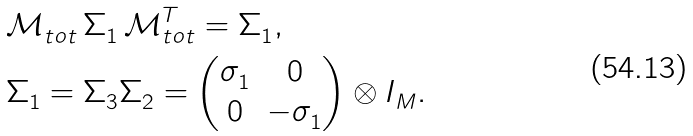Convert formula to latex. <formula><loc_0><loc_0><loc_500><loc_500>& \mathcal { M } ^ { \ } _ { t o t } \, \Sigma ^ { \ } _ { 1 } \, \mathcal { M } ^ { T } _ { t o t } = \Sigma ^ { \ } _ { 1 } , \\ & \Sigma ^ { \ } _ { 1 } = \Sigma ^ { \ } _ { 3 } \Sigma ^ { \ } _ { 2 } = \begin{pmatrix} \sigma ^ { \ } _ { 1 } & 0 \\ 0 & - \sigma ^ { \ } _ { 1 } \end{pmatrix} \otimes I ^ { \ } _ { M } .</formula> 